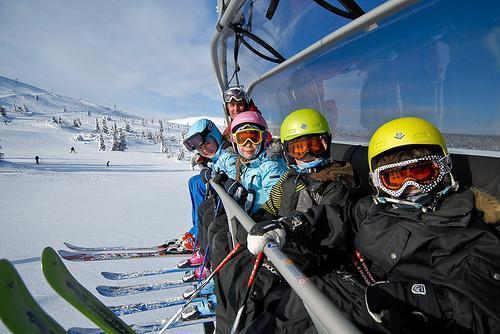How many people are sitting down?
Give a very brief answer. 5. How many helmets are yellow?
Give a very brief answer. 2. How many pink helmets are there?
Give a very brief answer. 1. 